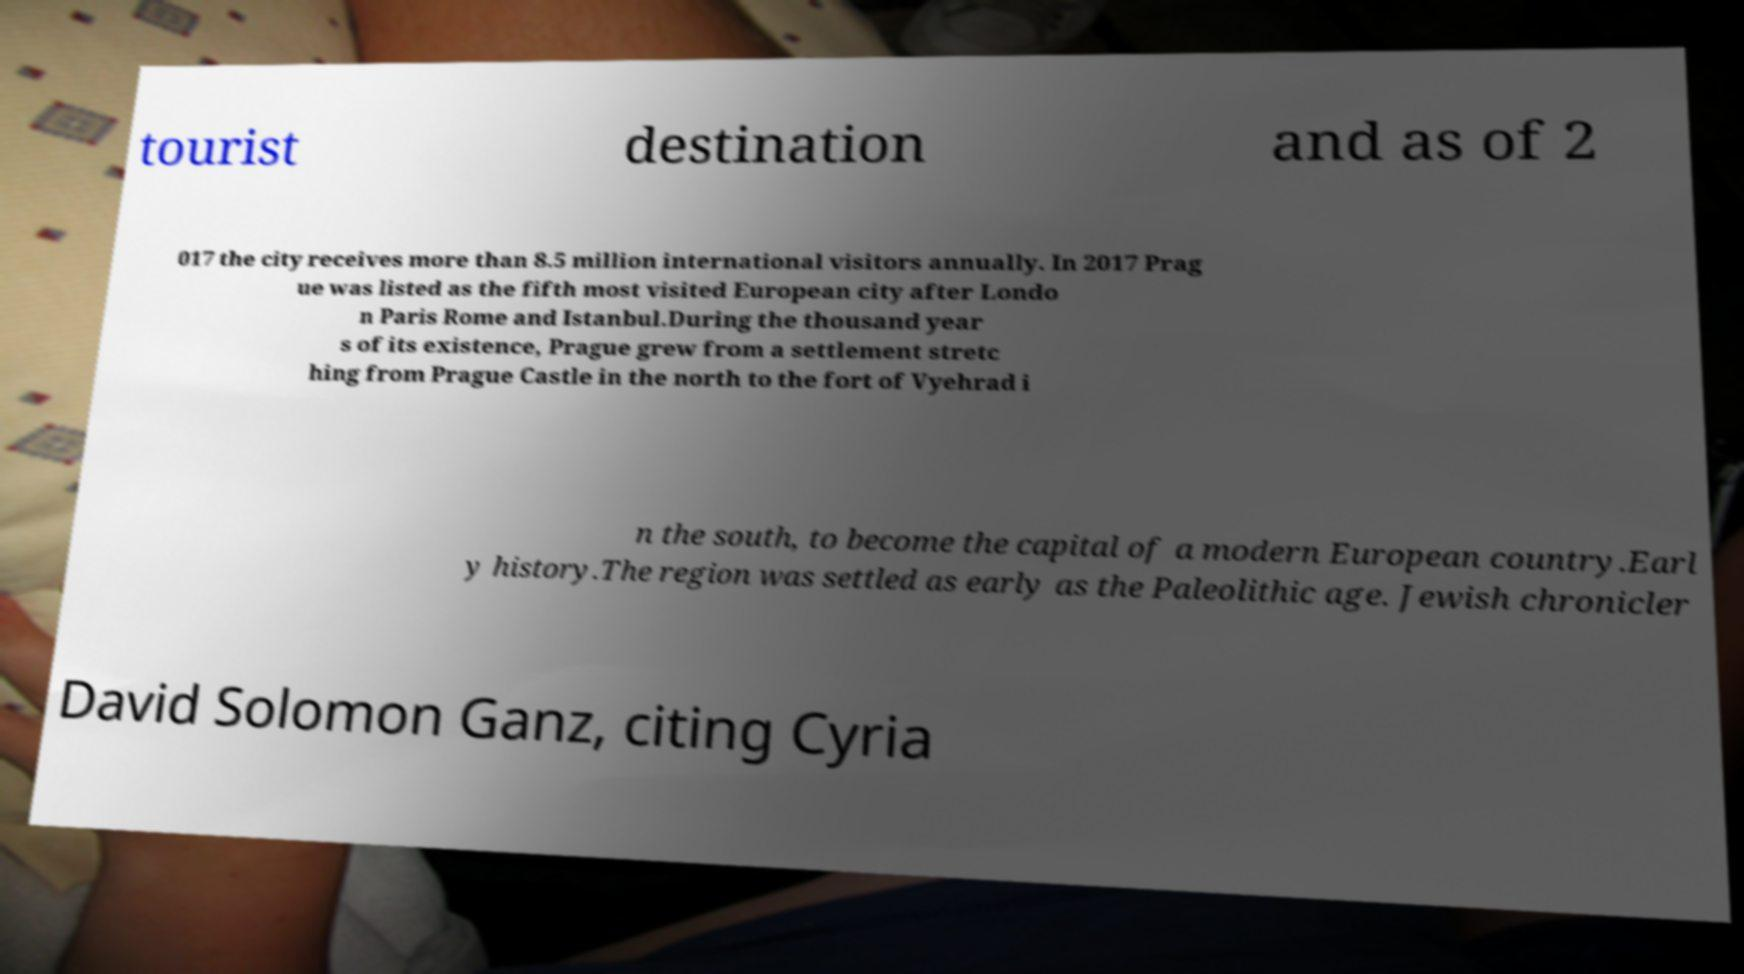I need the written content from this picture converted into text. Can you do that? tourist destination and as of 2 017 the city receives more than 8.5 million international visitors annually. In 2017 Prag ue was listed as the fifth most visited European city after Londo n Paris Rome and Istanbul.During the thousand year s of its existence, Prague grew from a settlement stretc hing from Prague Castle in the north to the fort of Vyehrad i n the south, to become the capital of a modern European country.Earl y history.The region was settled as early as the Paleolithic age. Jewish chronicler David Solomon Ganz, citing Cyria 